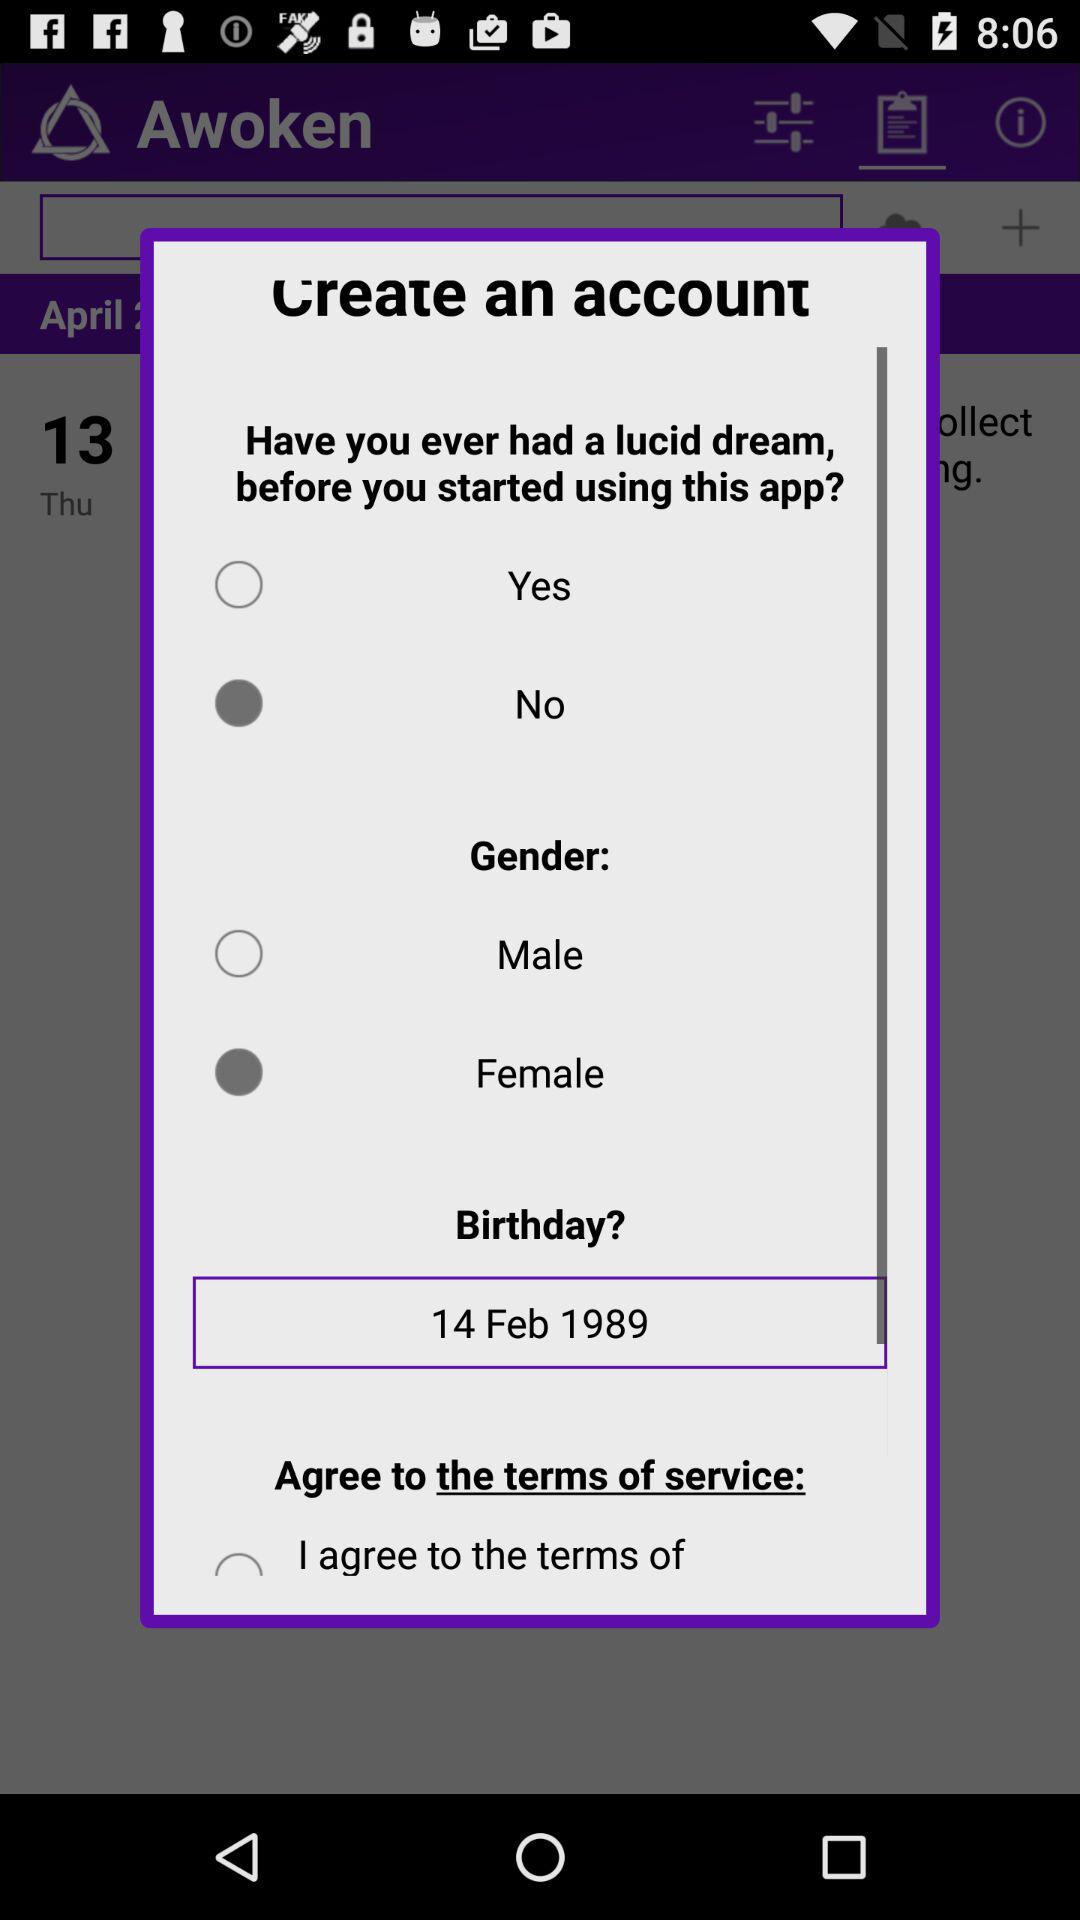What is the birthdate? The birthdate is 14 February 1989. 